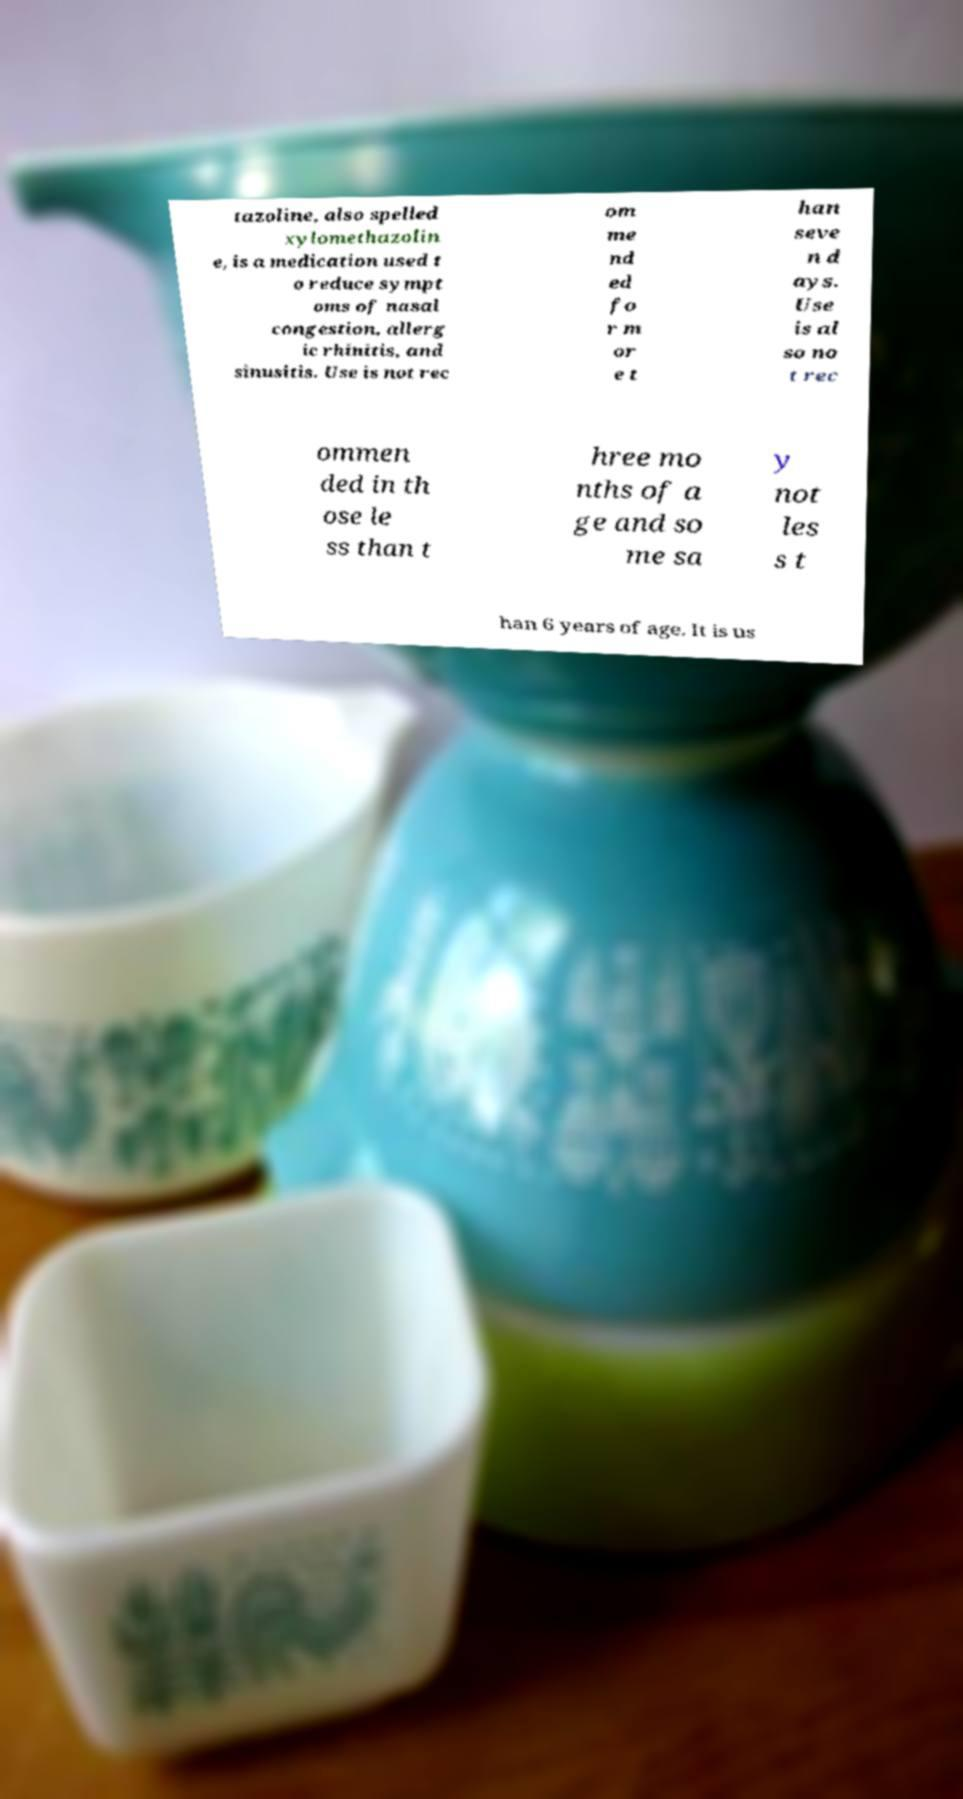Can you read and provide the text displayed in the image?This photo seems to have some interesting text. Can you extract and type it out for me? tazoline, also spelled xylomethazolin e, is a medication used t o reduce sympt oms of nasal congestion, allerg ic rhinitis, and sinusitis. Use is not rec om me nd ed fo r m or e t han seve n d ays. Use is al so no t rec ommen ded in th ose le ss than t hree mo nths of a ge and so me sa y not les s t han 6 years of age. It is us 